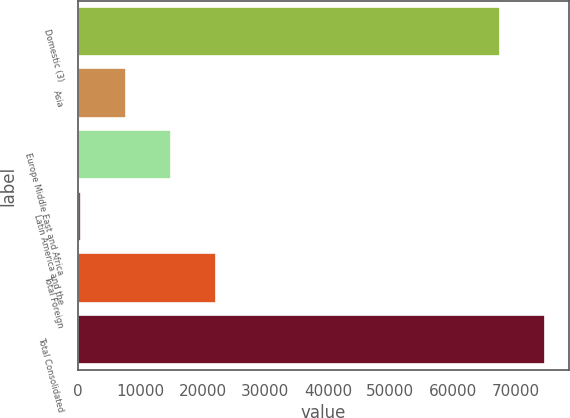<chart> <loc_0><loc_0><loc_500><loc_500><bar_chart><fcel>Domestic (3)<fcel>Asia<fcel>Europe Middle East and Africa<fcel>Latin America and the<fcel>Total Foreign<fcel>Total Consolidated<nl><fcel>67549<fcel>7676.9<fcel>14910.8<fcel>443<fcel>22144.7<fcel>74782.9<nl></chart> 